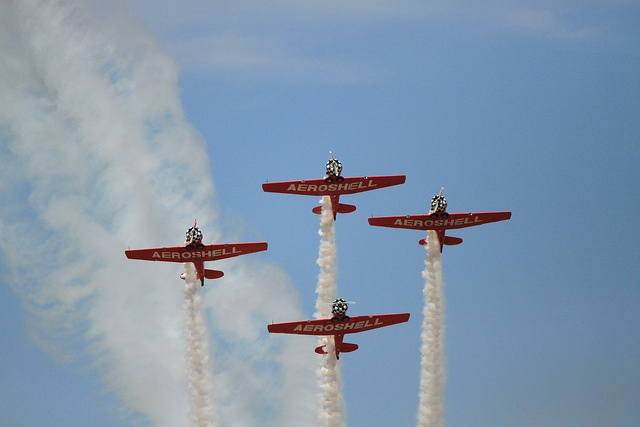Describe the objects in this image and their specific colors. I can see airplane in gray, maroon, and black tones, airplane in gray, maroon, darkgray, and black tones, airplane in gray, maroon, and black tones, and airplane in gray, maroon, and black tones in this image. 